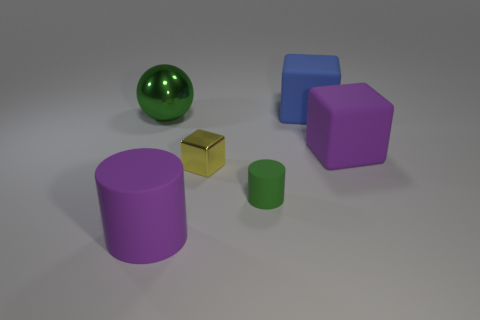Subtract all big matte blocks. How many blocks are left? 1 Subtract 1 cubes. How many cubes are left? 2 Add 1 green matte objects. How many objects exist? 7 Subtract all cylinders. How many objects are left? 4 Subtract 0 gray cylinders. How many objects are left? 6 Subtract all matte cubes. Subtract all large rubber cylinders. How many objects are left? 3 Add 6 small metal blocks. How many small metal blocks are left? 7 Add 2 purple matte cylinders. How many purple matte cylinders exist? 3 